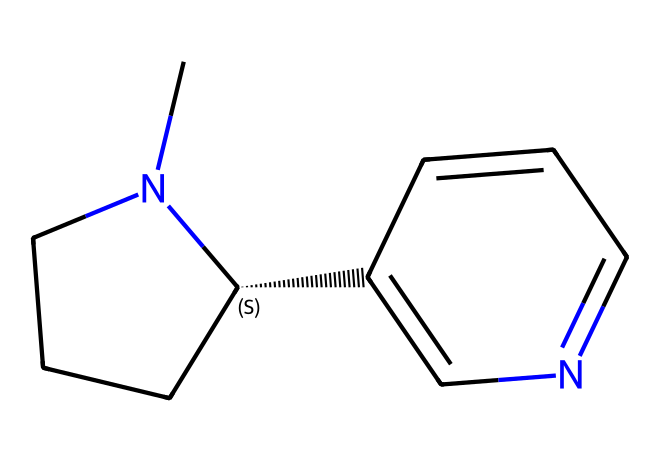What is the molecular formula of nicotine? To determine the molecular formula, count the number of carbon (C), hydrogen (H), and nitrogen (N) atoms in the chemical structure. The structure has 10 carbon atoms, 14 hydrogen atoms, and 2 nitrogen atoms, which leads to the formula C10H14N2.
Answer: C10H14N2 How many nitrogen atoms are present in nicotine? By examining the structure and identifying the nitrogen atoms, we can see there are 2 nitrogen atoms attached to the carbon chain in the molecule.
Answer: 2 What type of chemical is nicotine categorized as? Nicotine is classified as an alkaloid due to the presence of nitrogen atoms that participate in aromatic structures and its biological effects, which are characteristic of alkaloids.
Answer: alkaloid How many rings are present in the structure of nicotine? By analyzing the structure, you can see that there are two distinct rings formed by the arrangement of carbon and nitrogen atoms.
Answer: 2 What defines the addictive nature of nicotine based on its structure? The presence of nitrogen atoms and the specific arrangement in the rings allow nicotine to bind to nicotinic acetylcholine receptors in the brain, a key factor contributing to its addictive properties.
Answer: binding What is the main functional group in nicotine? The prominent feature of nicotine is the presence of a pyridine ring, which contains a nitrogen atom characteristic of heterocyclic compounds; this makes it the functional group of interest.
Answer: pyridine What is the basic skeleton of the nicotine molecule? The basic skeleton can be identified as a combination of a pyridine and a piperidine ring, which are interlinked in the chemical structure, constituting the backbone.
Answer: piperidine-pyridine 